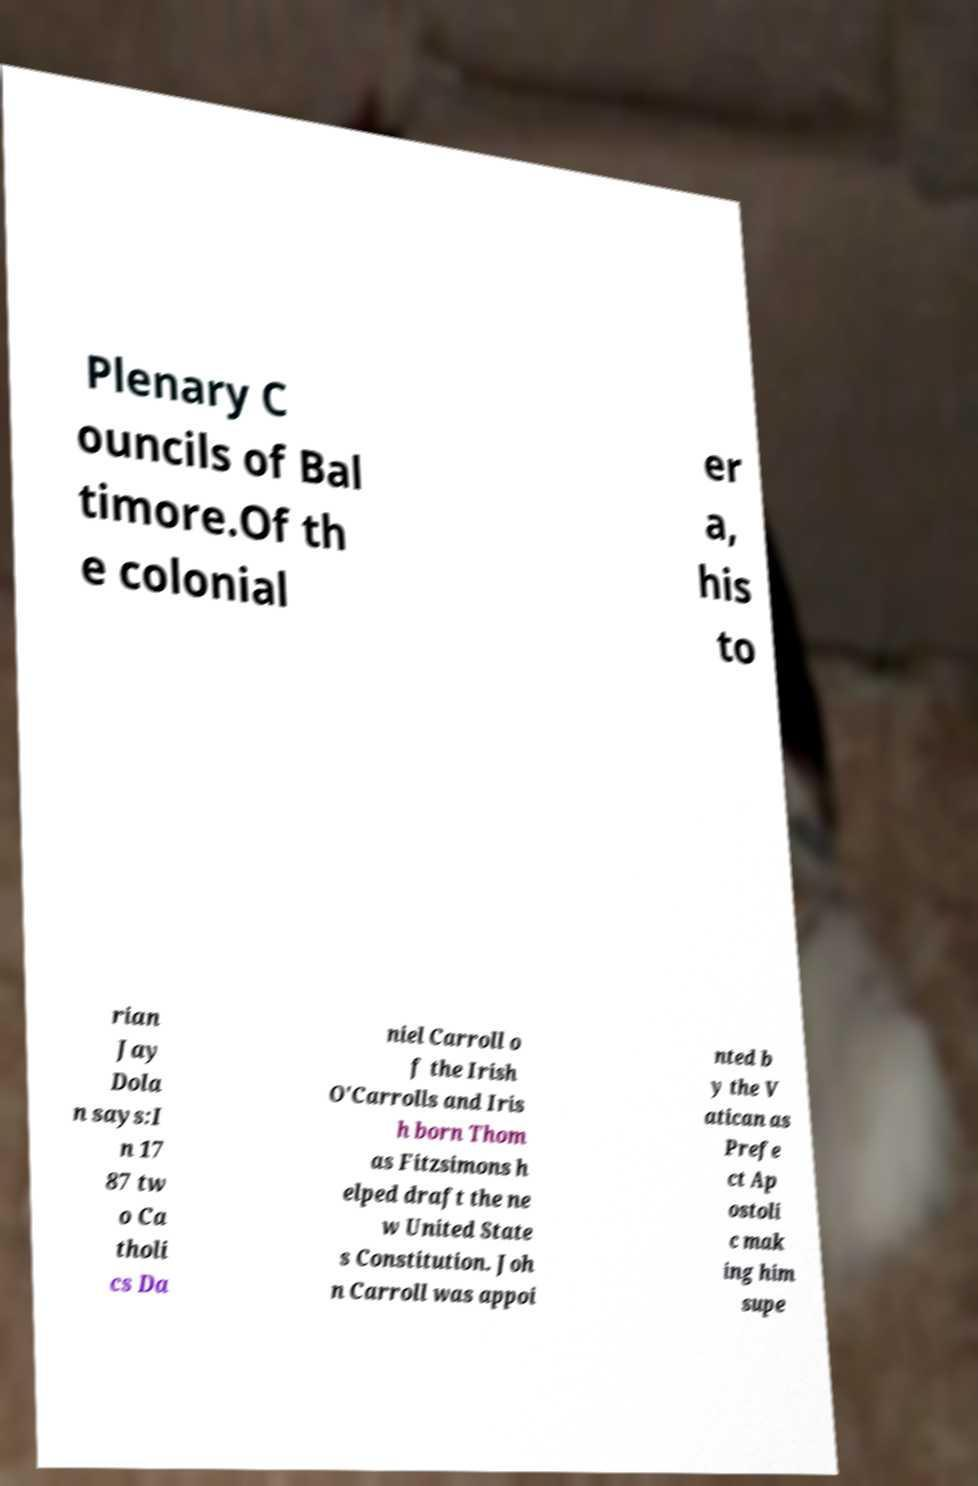Could you assist in decoding the text presented in this image and type it out clearly? Plenary C ouncils of Bal timore.Of th e colonial er a, his to rian Jay Dola n says:I n 17 87 tw o Ca tholi cs Da niel Carroll o f the Irish O'Carrolls and Iris h born Thom as Fitzsimons h elped draft the ne w United State s Constitution. Joh n Carroll was appoi nted b y the V atican as Prefe ct Ap ostoli c mak ing him supe 